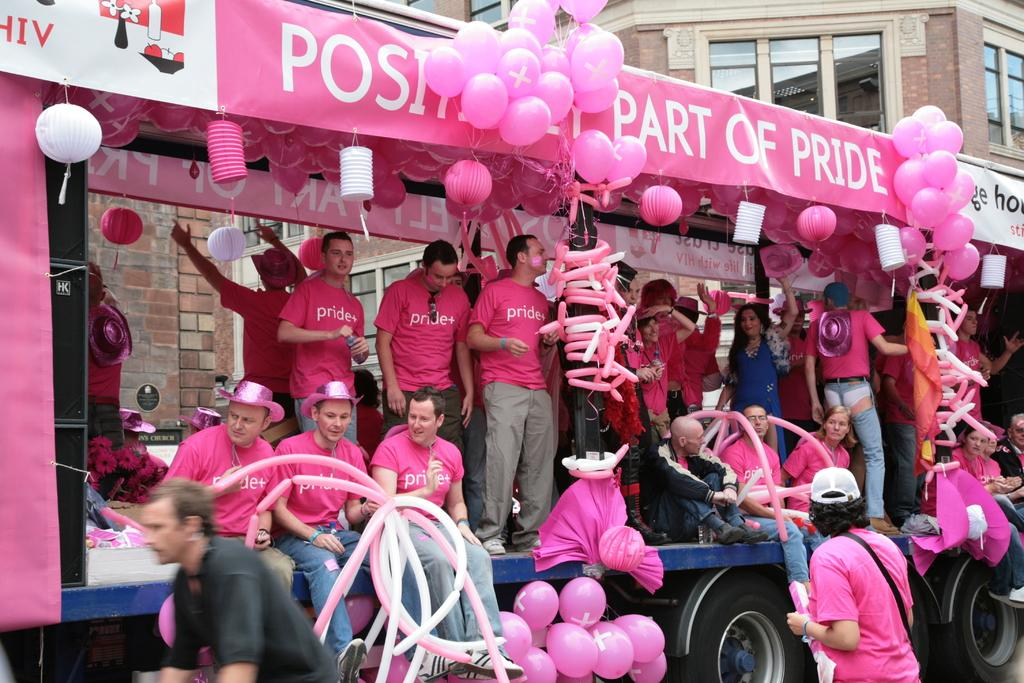Who or what can be seen in the image? There are people in the image. What type of object is also present in the image? There is a vehicle in the image. What additional decorative elements are visible? Balloons, banners, and decorative objects are present in the image. What can be seen in the background of the image? There is a building, windows, and a wall in the background of the image. What year is depicted in the image? The image does not depict a specific year; it is a snapshot of a scene with people, a vehicle, and decorative elements. Can you see any pigs in the image? There are no pigs present in the image. 